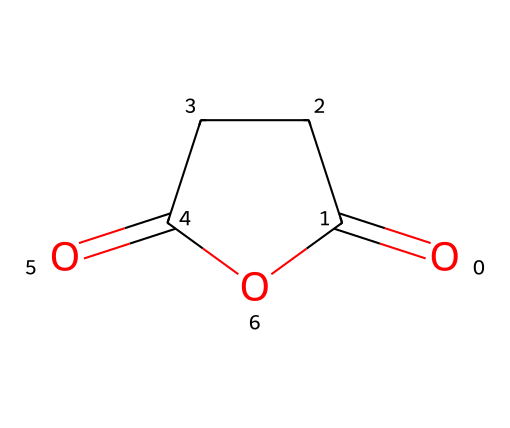What is the molecular formula of succinic anhydride? The structure of succinic anhydride shows that it contains two carbonyl groups (C=O) and four carbon atoms (C) overall. Thus, the molecular formula can be determined as C4H4O3.
Answer: C4H4O3 How many rings are present in the chemical structure? The chemical representation of succinic anhydride contains a cyclic structure, indicating that it has one ring formed by the connection of its atoms.
Answer: one What type of functional group is present in succinic anhydride? By analyzing the structure, we observe two carbonyl groups (C=O), which belong to the anhydride functional group. This characteristic defines succinic anhydride as an acid anhydride.
Answer: anhydride How many carbon atoms are in succinic anhydride? Examining the structure reveals that there are four carbon atoms in total displayed in the cyclic arrangement.
Answer: four What is the effect of succinic anhydride in flame retardants? Succinic anhydride plays a crucial role in flame retardants due to its ability to promote char formation when exposed to high temperatures, which helps to inhibit combustion.
Answer: char formation Is succinic anhydride a saturated or unsaturated compound? The presence of carbonyl bonds (C=O) in the structure indicates that succinic anhydride is not fully saturated, hence it is classified as an unsaturated compound.
Answer: unsaturated 